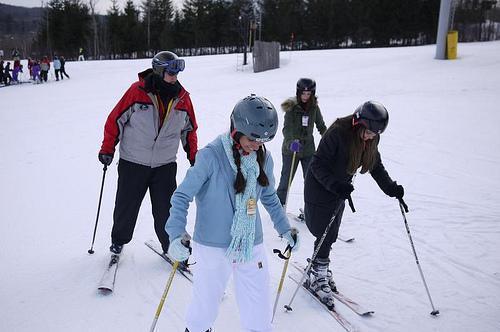How many people in the family closer to the camera?
Give a very brief answer. 4. 